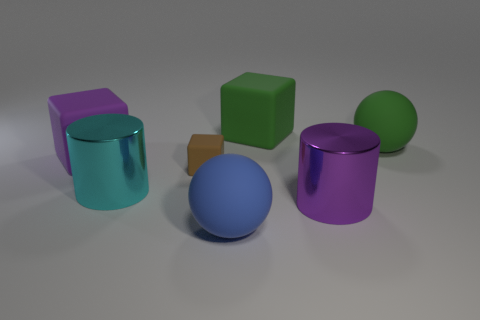Add 1 large objects. How many objects exist? 8 Subtract all large matte blocks. How many blocks are left? 1 Subtract all green cubes. How many cubes are left? 2 Add 3 gray metallic cubes. How many gray metallic cubes exist? 3 Subtract 1 blue balls. How many objects are left? 6 Subtract all blocks. How many objects are left? 4 Subtract 1 cylinders. How many cylinders are left? 1 Subtract all cyan cylinders. Subtract all gray spheres. How many cylinders are left? 1 Subtract all cyan cylinders. How many red balls are left? 0 Subtract all green matte things. Subtract all rubber cubes. How many objects are left? 2 